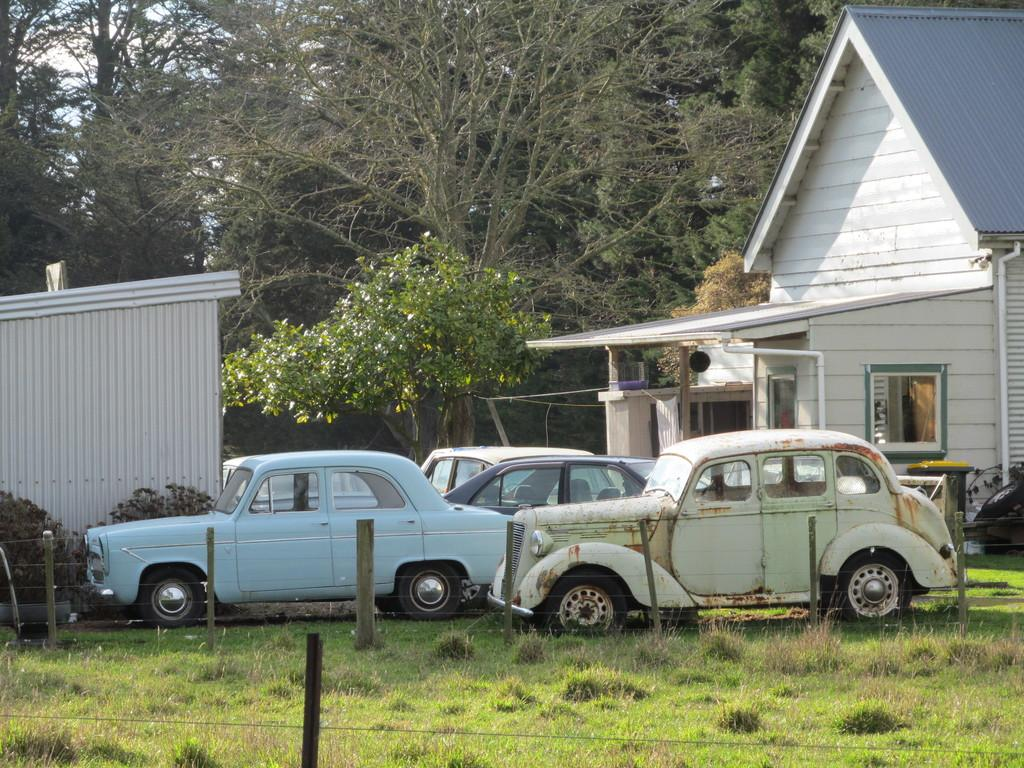What type of vegetation can be seen in the image? There is green grass in the image. What is the purpose of the fencing in the image? The fencing in the image serves as a boundary or barrier. What type of vehicles are present in the image? There are cars in the image. What type of building can be seen in the image? There is a house in the image. What can be seen in the background of the image? There are trees in the background of the image. What part of the natural environment is visible in the image? The sky is visible in the image. What other type of vegetation is present in the image? There are plants in the image. Can you see a girl applying lipstick in the image? There is no girl applying lipstick in the image. What part of the house is missing in the image? The image does not show any part of the house missing; it only shows the house as a whole. 